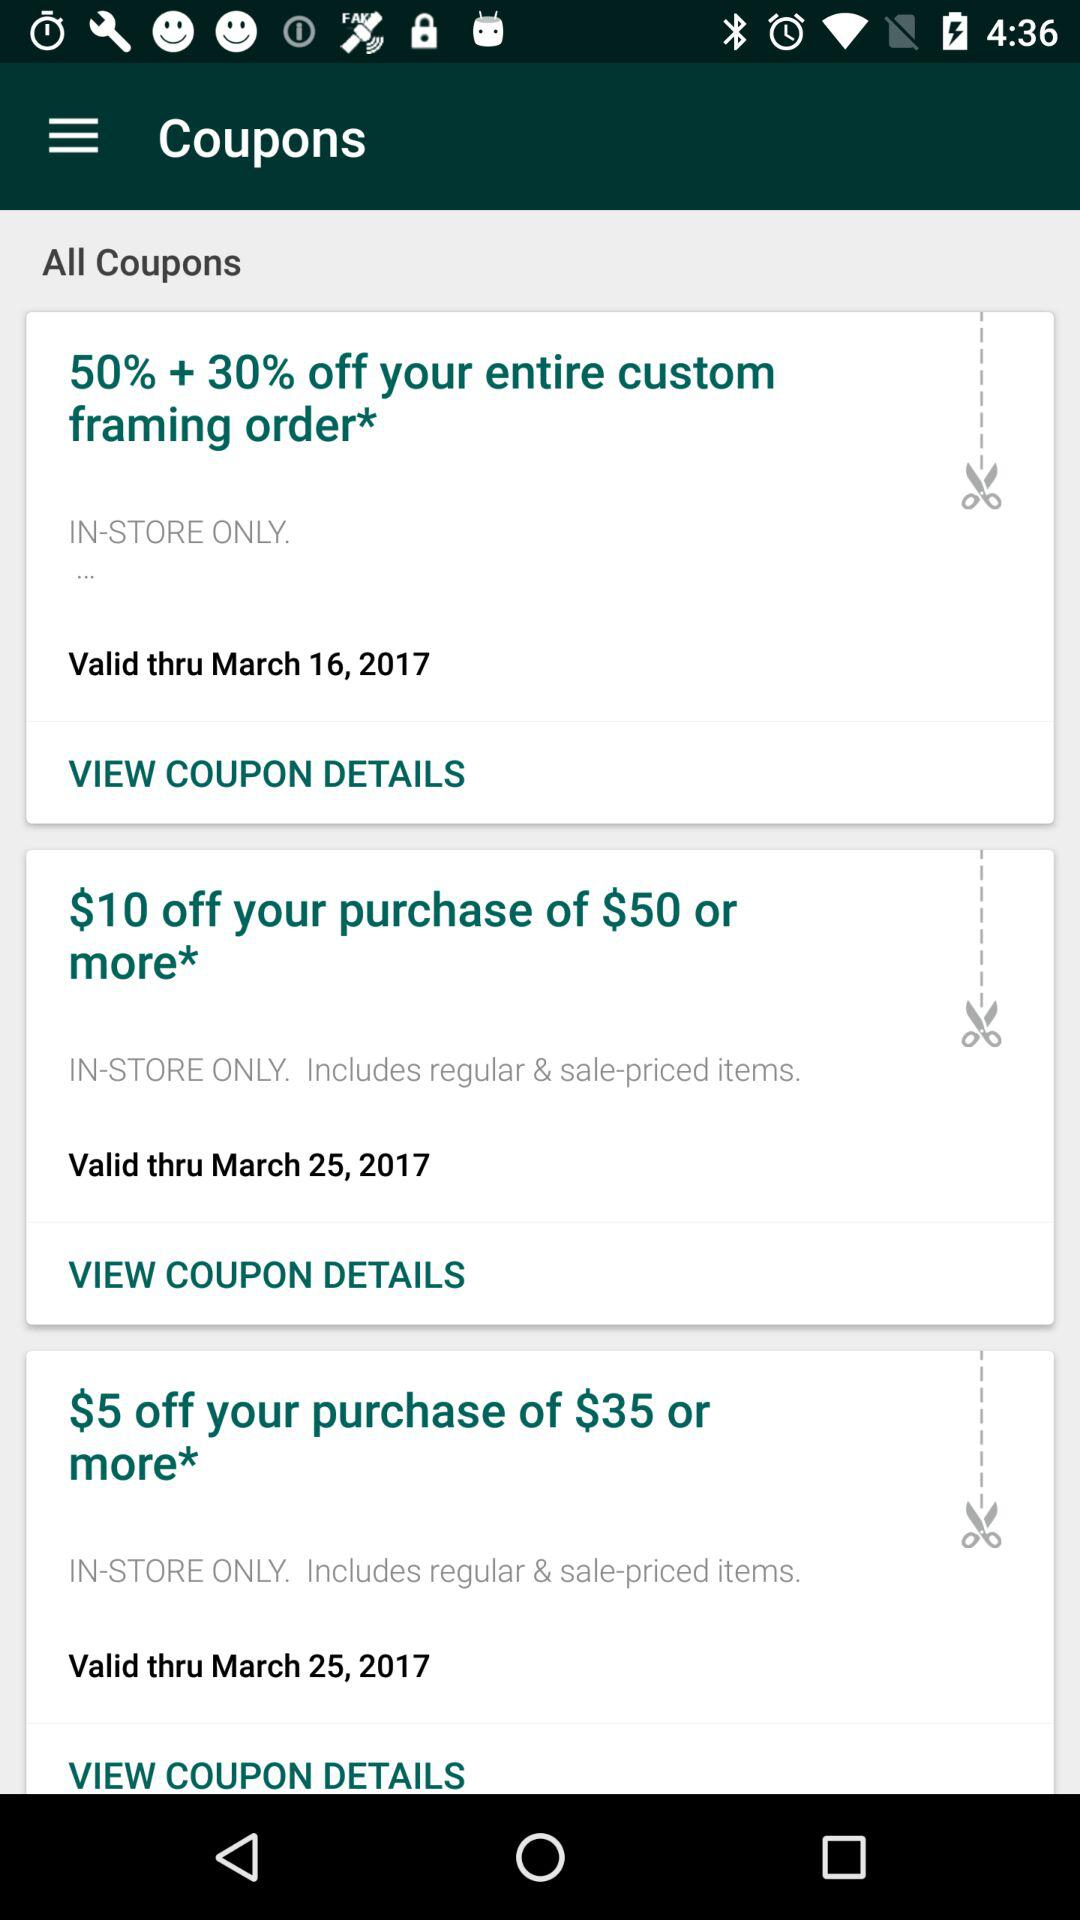How many coupons are offered in total?
Answer the question using a single word or phrase. 3 